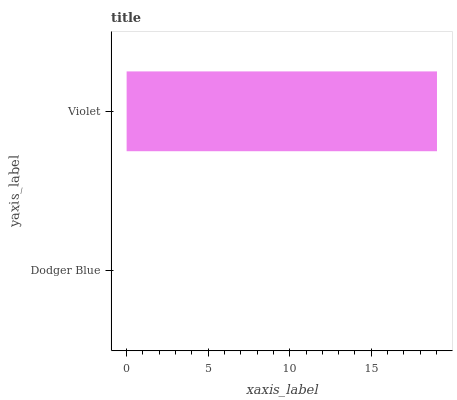Is Dodger Blue the minimum?
Answer yes or no. Yes. Is Violet the maximum?
Answer yes or no. Yes. Is Violet the minimum?
Answer yes or no. No. Is Violet greater than Dodger Blue?
Answer yes or no. Yes. Is Dodger Blue less than Violet?
Answer yes or no. Yes. Is Dodger Blue greater than Violet?
Answer yes or no. No. Is Violet less than Dodger Blue?
Answer yes or no. No. Is Violet the high median?
Answer yes or no. Yes. Is Dodger Blue the low median?
Answer yes or no. Yes. Is Dodger Blue the high median?
Answer yes or no. No. Is Violet the low median?
Answer yes or no. No. 